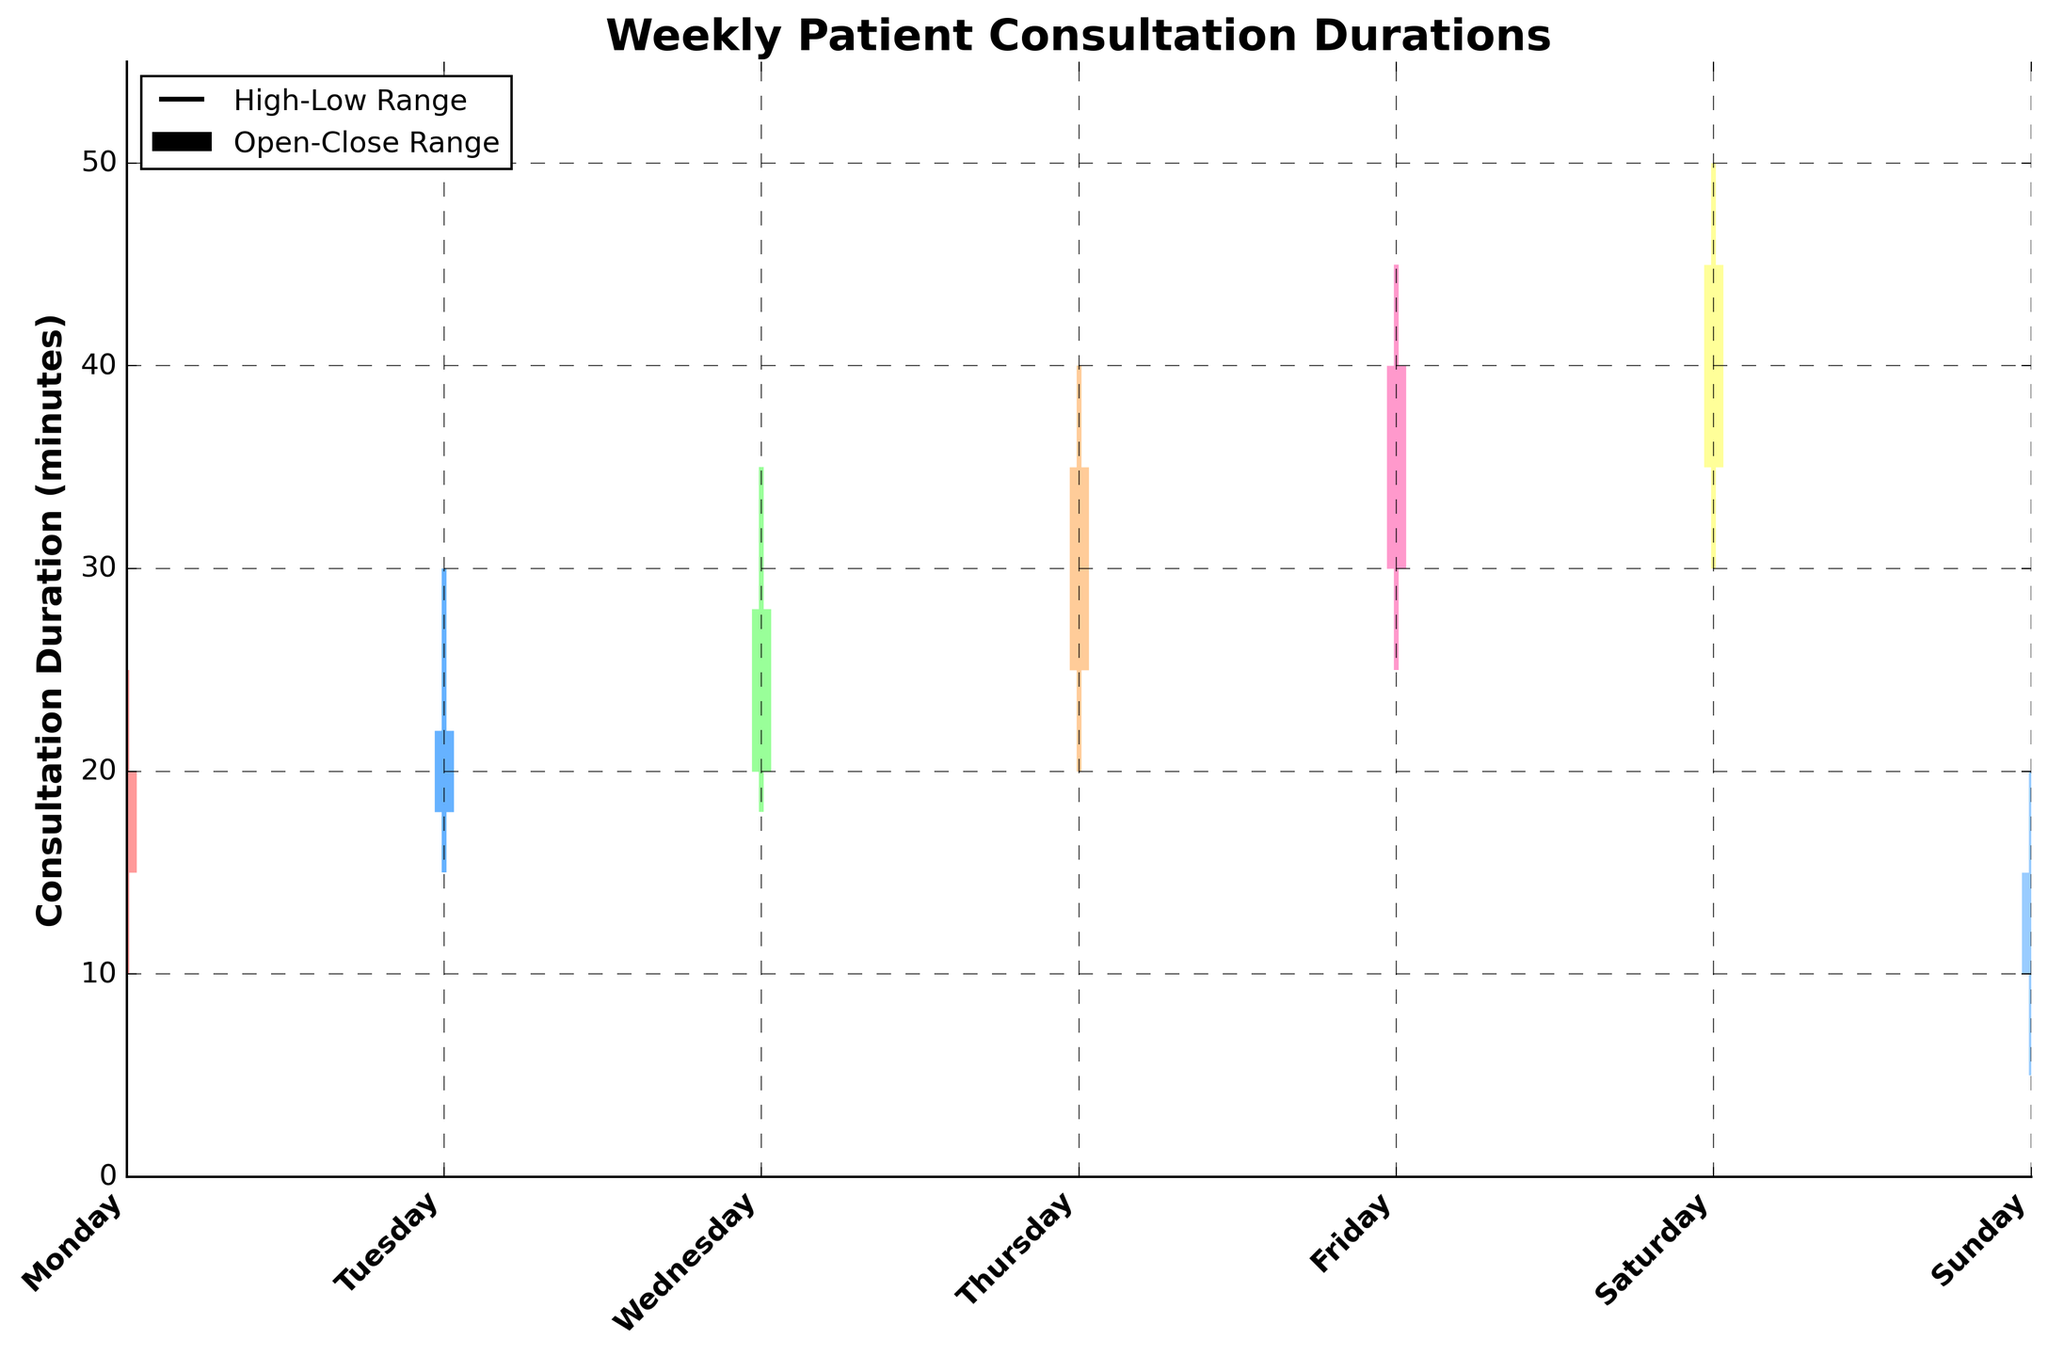What is the title of the chart? The title is written at the top of the chart. It provides an overview of what the chart represents.
Answer: Weekly Patient Consultation Durations What is the maximum consultation duration recorded on Friday? Look for the highest point represented on the chart for Friday, which is indicated by the top of the vertical line.
Answer: 45 minutes Which day has the shortest consultation duration recorded? Observe the lowest point across all the vertical lines in the chart; it is where the line reaches the minimum.
Answer: Sunday On which day did the consultation duration range (difference between high and low) have the greatest variability? Calculate the difference between the high and low values for each day and compare them. The greatest difference indicates the highest variability. For example: Monday (25-10=15), Tuesday (30-15=15), Wednesday (35-18=17), Thursday (40-20=20), Friday (45-25=20), Saturday (50-30=20), Sunday (20-5=15).
Answer: Saturday Which days have consultation durations that start at 20 minutes or higher or end at 40 minutes or lower? Identify days where the "Open" value is 20 or higher or the "Close" value is 40 or lower by checking the OHLC values.
Answer: Wednesday, Thursday, Friday, Saturday What is the average closing duration for the entire week? Sum up all the "Close" values and divide by the total number of days. (20 + 22 + 28 + 35 + 40 + 45 + 15) / 7 = 205 / 7 = 29.29 minutes.
Answer: 29.29 minutes Which day shows the largest increase in consultation duration from Open to Close? Calculate the difference between the "Open" and "Close" values for each day and identify the largest increase. For example: Monday (20-15=5), Tuesday (22-18=4), Wednesday (28-20=8), Thursday (35-25=10), Friday (40-30=10), Saturday (45-35=10), Sunday (15-10=5).
Answer: Thursday How many unique colors are used to represent different days in the chart? Count the distinct colors used for the vertical lines and the thick bars representing the different days.
Answer: 7 On which day was the consultation duration closed higher than it opened? Find the days where the "Close" value is greater than the "Open" value by scanning through the OHLC values. All values that meet this criterion should be listed.
Answer: All days except Sunday What is the overall range of consultation durations recorded in the week? Determine the absolute maximum and minimum values from the "High" and "Low" data points across all days. The range is from the lowest minimum to the highest maximum (50-5=45).
Answer: 45 minutes 